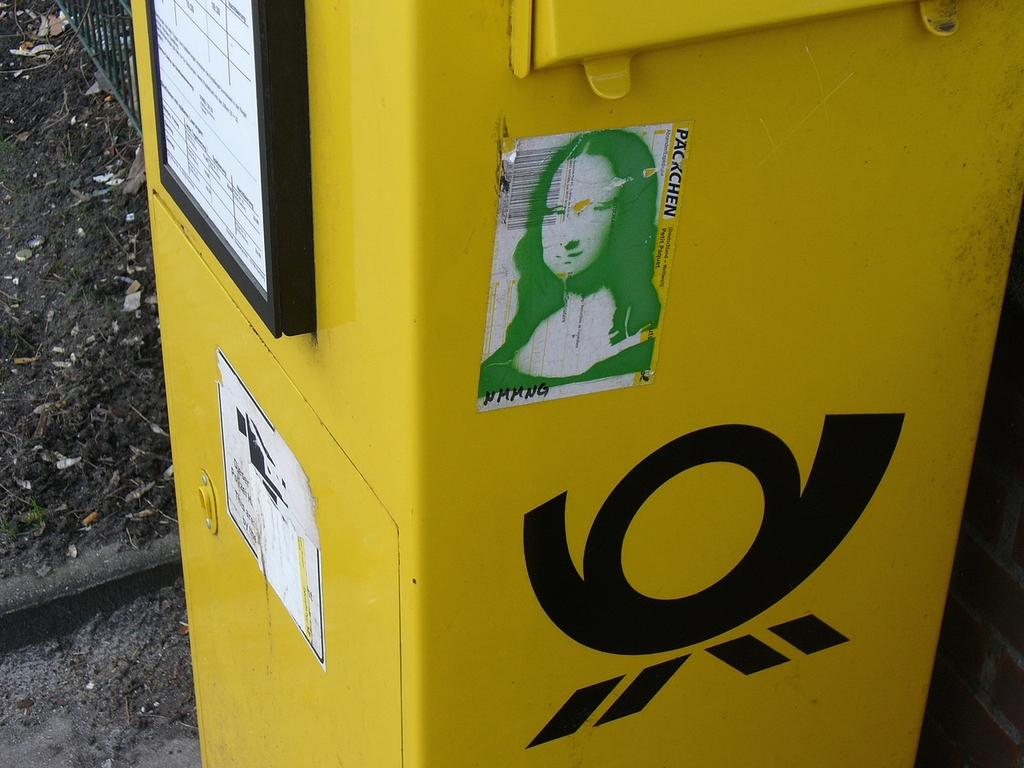<image>
Offer a succinct explanation of the picture presented. A yellow bin has a sticker with th Mona Lisa and the word Packchen. 